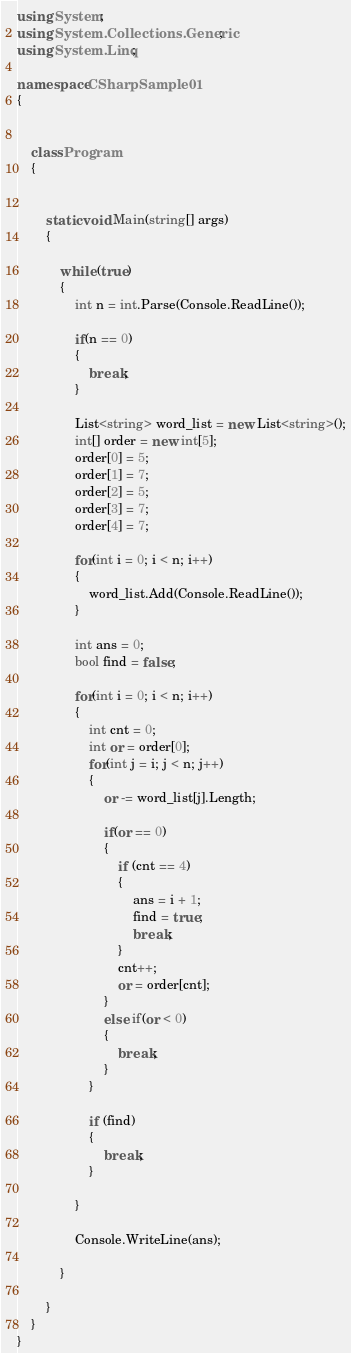Convert code to text. <code><loc_0><loc_0><loc_500><loc_500><_C#_>using System;
using System.Collections.Generic;
using System.Linq;

namespace CSharpSample01
{
    

    class Program
    {
        
        
        static void Main(string[] args)
        {

            while (true)
            {
                int n = int.Parse(Console.ReadLine());

                if(n == 0)
                {
                    break;
                }

                List<string> word_list = new List<string>();
                int[] order = new int[5];
                order[0] = 5;
                order[1] = 7;
                order[2] = 5;
                order[3] = 7;
                order[4] = 7;

                for(int i = 0; i < n; i++)
                {
                    word_list.Add(Console.ReadLine());
                }

                int ans = 0;
                bool find = false;

                for(int i = 0; i < n; i++)
                {
                    int cnt = 0;
                    int or = order[0];
                    for(int j = i; j < n; j++)
                    {
                        or -= word_list[j].Length;

                        if(or == 0)
                        {
                            if (cnt == 4)
                            {
                                ans = i + 1;
                                find = true;
                                break;
                            }
                            cnt++;
                            or = order[cnt];
                        }
                        else if(or < 0)
                        {
                            break;
                        }
                    }

                    if (find)
                    {
                        break;
                    }

                }

                Console.WriteLine(ans);

            }
            
        }
    }
}
</code> 